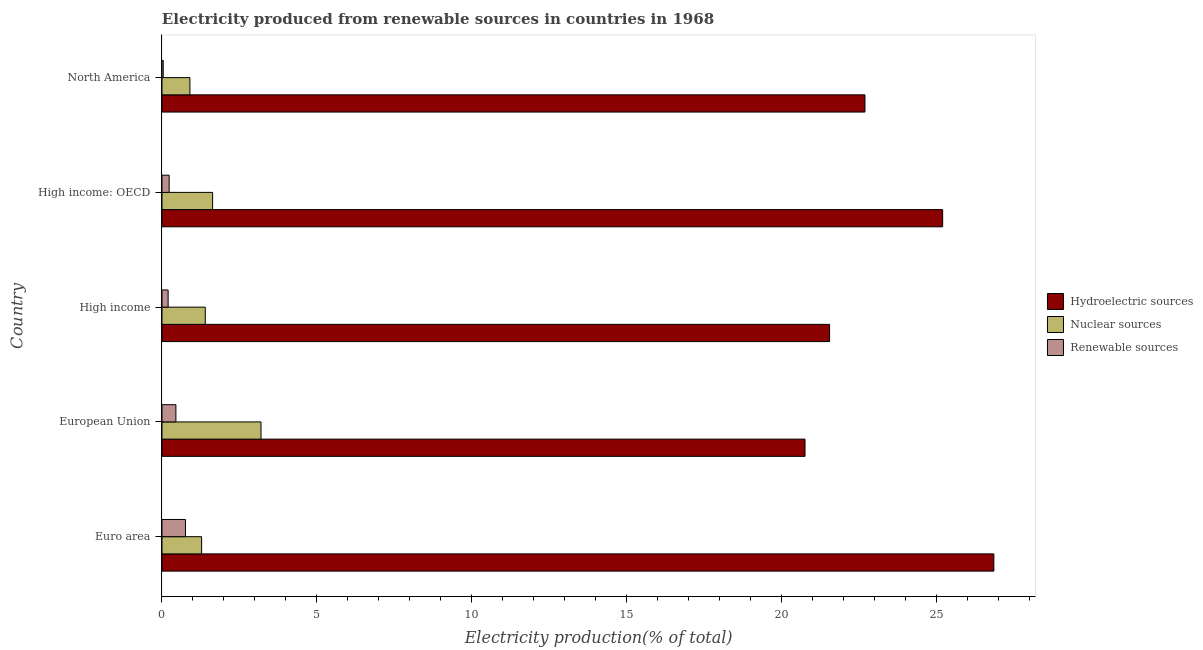How many different coloured bars are there?
Your answer should be very brief. 3. Are the number of bars per tick equal to the number of legend labels?
Your answer should be compact. Yes. Are the number of bars on each tick of the Y-axis equal?
Ensure brevity in your answer.  Yes. How many bars are there on the 1st tick from the top?
Keep it short and to the point. 3. What is the percentage of electricity produced by renewable sources in European Union?
Offer a very short reply. 0.45. Across all countries, what is the maximum percentage of electricity produced by hydroelectric sources?
Ensure brevity in your answer.  26.85. Across all countries, what is the minimum percentage of electricity produced by hydroelectric sources?
Offer a terse response. 20.75. In which country was the percentage of electricity produced by renewable sources maximum?
Offer a terse response. Euro area. What is the total percentage of electricity produced by renewable sources in the graph?
Your response must be concise. 1.68. What is the difference between the percentage of electricity produced by nuclear sources in Euro area and that in High income?
Your answer should be compact. -0.12. What is the difference between the percentage of electricity produced by hydroelectric sources in Euro area and the percentage of electricity produced by nuclear sources in High income: OECD?
Your answer should be compact. 25.21. What is the average percentage of electricity produced by hydroelectric sources per country?
Ensure brevity in your answer.  23.4. What is the difference between the percentage of electricity produced by hydroelectric sources and percentage of electricity produced by renewable sources in European Union?
Your answer should be very brief. 20.3. What is the ratio of the percentage of electricity produced by hydroelectric sources in European Union to that in High income?
Offer a very short reply. 0.96. Is the percentage of electricity produced by renewable sources in High income less than that in High income: OECD?
Provide a short and direct response. Yes. Is the difference between the percentage of electricity produced by hydroelectric sources in High income: OECD and North America greater than the difference between the percentage of electricity produced by renewable sources in High income: OECD and North America?
Make the answer very short. Yes. What is the difference between the highest and the second highest percentage of electricity produced by nuclear sources?
Keep it short and to the point. 1.56. What is the difference between the highest and the lowest percentage of electricity produced by nuclear sources?
Offer a very short reply. 2.29. What does the 2nd bar from the top in North America represents?
Offer a very short reply. Nuclear sources. What does the 3rd bar from the bottom in High income represents?
Offer a terse response. Renewable sources. How many bars are there?
Your answer should be very brief. 15. Are all the bars in the graph horizontal?
Provide a short and direct response. Yes. Are the values on the major ticks of X-axis written in scientific E-notation?
Provide a succinct answer. No. Does the graph contain any zero values?
Provide a short and direct response. No. Does the graph contain grids?
Your answer should be compact. No. Where does the legend appear in the graph?
Offer a terse response. Center right. How many legend labels are there?
Your answer should be compact. 3. What is the title of the graph?
Offer a terse response. Electricity produced from renewable sources in countries in 1968. Does "Resident buildings and public services" appear as one of the legend labels in the graph?
Give a very brief answer. No. What is the label or title of the X-axis?
Provide a succinct answer. Electricity production(% of total). What is the label or title of the Y-axis?
Keep it short and to the point. Country. What is the Electricity production(% of total) in Hydroelectric sources in Euro area?
Provide a short and direct response. 26.85. What is the Electricity production(% of total) of Nuclear sources in Euro area?
Keep it short and to the point. 1.28. What is the Electricity production(% of total) of Renewable sources in Euro area?
Offer a very short reply. 0.76. What is the Electricity production(% of total) in Hydroelectric sources in European Union?
Give a very brief answer. 20.75. What is the Electricity production(% of total) of Nuclear sources in European Union?
Give a very brief answer. 3.2. What is the Electricity production(% of total) of Renewable sources in European Union?
Provide a succinct answer. 0.45. What is the Electricity production(% of total) of Hydroelectric sources in High income?
Your answer should be compact. 21.54. What is the Electricity production(% of total) in Nuclear sources in High income?
Provide a short and direct response. 1.4. What is the Electricity production(% of total) of Renewable sources in High income?
Your answer should be compact. 0.2. What is the Electricity production(% of total) of Hydroelectric sources in High income: OECD?
Your response must be concise. 25.19. What is the Electricity production(% of total) in Nuclear sources in High income: OECD?
Your answer should be very brief. 1.63. What is the Electricity production(% of total) in Renewable sources in High income: OECD?
Your answer should be compact. 0.23. What is the Electricity production(% of total) of Hydroelectric sources in North America?
Keep it short and to the point. 22.69. What is the Electricity production(% of total) in Nuclear sources in North America?
Provide a succinct answer. 0.9. What is the Electricity production(% of total) in Renewable sources in North America?
Offer a terse response. 0.04. Across all countries, what is the maximum Electricity production(% of total) in Hydroelectric sources?
Your response must be concise. 26.85. Across all countries, what is the maximum Electricity production(% of total) of Nuclear sources?
Your answer should be very brief. 3.2. Across all countries, what is the maximum Electricity production(% of total) of Renewable sources?
Offer a terse response. 0.76. Across all countries, what is the minimum Electricity production(% of total) of Hydroelectric sources?
Make the answer very short. 20.75. Across all countries, what is the minimum Electricity production(% of total) of Nuclear sources?
Give a very brief answer. 0.9. Across all countries, what is the minimum Electricity production(% of total) in Renewable sources?
Your response must be concise. 0.04. What is the total Electricity production(% of total) in Hydroelectric sources in the graph?
Offer a very short reply. 117.02. What is the total Electricity production(% of total) in Nuclear sources in the graph?
Your response must be concise. 8.41. What is the total Electricity production(% of total) of Renewable sources in the graph?
Offer a very short reply. 1.68. What is the difference between the Electricity production(% of total) of Hydroelectric sources in Euro area and that in European Union?
Your answer should be compact. 6.09. What is the difference between the Electricity production(% of total) of Nuclear sources in Euro area and that in European Union?
Offer a terse response. -1.92. What is the difference between the Electricity production(% of total) in Renewable sources in Euro area and that in European Union?
Your response must be concise. 0.31. What is the difference between the Electricity production(% of total) of Hydroelectric sources in Euro area and that in High income?
Make the answer very short. 5.3. What is the difference between the Electricity production(% of total) of Nuclear sources in Euro area and that in High income?
Your answer should be very brief. -0.12. What is the difference between the Electricity production(% of total) in Renewable sources in Euro area and that in High income?
Keep it short and to the point. 0.56. What is the difference between the Electricity production(% of total) in Hydroelectric sources in Euro area and that in High income: OECD?
Provide a succinct answer. 1.65. What is the difference between the Electricity production(% of total) of Nuclear sources in Euro area and that in High income: OECD?
Provide a short and direct response. -0.36. What is the difference between the Electricity production(% of total) of Renewable sources in Euro area and that in High income: OECD?
Offer a terse response. 0.53. What is the difference between the Electricity production(% of total) in Hydroelectric sources in Euro area and that in North America?
Your response must be concise. 4.16. What is the difference between the Electricity production(% of total) in Nuclear sources in Euro area and that in North America?
Ensure brevity in your answer.  0.38. What is the difference between the Electricity production(% of total) in Renewable sources in Euro area and that in North America?
Provide a short and direct response. 0.72. What is the difference between the Electricity production(% of total) of Hydroelectric sources in European Union and that in High income?
Provide a succinct answer. -0.79. What is the difference between the Electricity production(% of total) in Nuclear sources in European Union and that in High income?
Ensure brevity in your answer.  1.8. What is the difference between the Electricity production(% of total) of Renewable sources in European Union and that in High income?
Your answer should be very brief. 0.25. What is the difference between the Electricity production(% of total) of Hydroelectric sources in European Union and that in High income: OECD?
Offer a terse response. -4.44. What is the difference between the Electricity production(% of total) of Nuclear sources in European Union and that in High income: OECD?
Keep it short and to the point. 1.56. What is the difference between the Electricity production(% of total) in Renewable sources in European Union and that in High income: OECD?
Give a very brief answer. 0.22. What is the difference between the Electricity production(% of total) in Hydroelectric sources in European Union and that in North America?
Your response must be concise. -1.93. What is the difference between the Electricity production(% of total) of Nuclear sources in European Union and that in North America?
Offer a very short reply. 2.29. What is the difference between the Electricity production(% of total) in Renewable sources in European Union and that in North America?
Offer a very short reply. 0.41. What is the difference between the Electricity production(% of total) in Hydroelectric sources in High income and that in High income: OECD?
Make the answer very short. -3.65. What is the difference between the Electricity production(% of total) of Nuclear sources in High income and that in High income: OECD?
Offer a very short reply. -0.24. What is the difference between the Electricity production(% of total) in Renewable sources in High income and that in High income: OECD?
Make the answer very short. -0.03. What is the difference between the Electricity production(% of total) of Hydroelectric sources in High income and that in North America?
Offer a very short reply. -1.14. What is the difference between the Electricity production(% of total) of Nuclear sources in High income and that in North America?
Offer a very short reply. 0.5. What is the difference between the Electricity production(% of total) in Renewable sources in High income and that in North America?
Provide a short and direct response. 0.16. What is the difference between the Electricity production(% of total) of Hydroelectric sources in High income: OECD and that in North America?
Keep it short and to the point. 2.51. What is the difference between the Electricity production(% of total) of Nuclear sources in High income: OECD and that in North America?
Offer a very short reply. 0.73. What is the difference between the Electricity production(% of total) in Renewable sources in High income: OECD and that in North America?
Make the answer very short. 0.19. What is the difference between the Electricity production(% of total) of Hydroelectric sources in Euro area and the Electricity production(% of total) of Nuclear sources in European Union?
Offer a very short reply. 23.65. What is the difference between the Electricity production(% of total) in Hydroelectric sources in Euro area and the Electricity production(% of total) in Renewable sources in European Union?
Provide a succinct answer. 26.4. What is the difference between the Electricity production(% of total) in Nuclear sources in Euro area and the Electricity production(% of total) in Renewable sources in European Union?
Your answer should be compact. 0.83. What is the difference between the Electricity production(% of total) of Hydroelectric sources in Euro area and the Electricity production(% of total) of Nuclear sources in High income?
Your answer should be compact. 25.45. What is the difference between the Electricity production(% of total) of Hydroelectric sources in Euro area and the Electricity production(% of total) of Renewable sources in High income?
Ensure brevity in your answer.  26.65. What is the difference between the Electricity production(% of total) in Nuclear sources in Euro area and the Electricity production(% of total) in Renewable sources in High income?
Give a very brief answer. 1.08. What is the difference between the Electricity production(% of total) of Hydroelectric sources in Euro area and the Electricity production(% of total) of Nuclear sources in High income: OECD?
Your response must be concise. 25.21. What is the difference between the Electricity production(% of total) in Hydroelectric sources in Euro area and the Electricity production(% of total) in Renewable sources in High income: OECD?
Provide a succinct answer. 26.61. What is the difference between the Electricity production(% of total) in Nuclear sources in Euro area and the Electricity production(% of total) in Renewable sources in High income: OECD?
Provide a short and direct response. 1.05. What is the difference between the Electricity production(% of total) of Hydroelectric sources in Euro area and the Electricity production(% of total) of Nuclear sources in North America?
Provide a succinct answer. 25.94. What is the difference between the Electricity production(% of total) in Hydroelectric sources in Euro area and the Electricity production(% of total) in Renewable sources in North America?
Offer a very short reply. 26.81. What is the difference between the Electricity production(% of total) of Nuclear sources in Euro area and the Electricity production(% of total) of Renewable sources in North America?
Your answer should be compact. 1.24. What is the difference between the Electricity production(% of total) in Hydroelectric sources in European Union and the Electricity production(% of total) in Nuclear sources in High income?
Your answer should be compact. 19.35. What is the difference between the Electricity production(% of total) of Hydroelectric sources in European Union and the Electricity production(% of total) of Renewable sources in High income?
Provide a short and direct response. 20.55. What is the difference between the Electricity production(% of total) in Nuclear sources in European Union and the Electricity production(% of total) in Renewable sources in High income?
Ensure brevity in your answer.  3. What is the difference between the Electricity production(% of total) in Hydroelectric sources in European Union and the Electricity production(% of total) in Nuclear sources in High income: OECD?
Make the answer very short. 19.12. What is the difference between the Electricity production(% of total) in Hydroelectric sources in European Union and the Electricity production(% of total) in Renewable sources in High income: OECD?
Your answer should be compact. 20.52. What is the difference between the Electricity production(% of total) of Nuclear sources in European Union and the Electricity production(% of total) of Renewable sources in High income: OECD?
Offer a very short reply. 2.96. What is the difference between the Electricity production(% of total) in Hydroelectric sources in European Union and the Electricity production(% of total) in Nuclear sources in North America?
Provide a succinct answer. 19.85. What is the difference between the Electricity production(% of total) of Hydroelectric sources in European Union and the Electricity production(% of total) of Renewable sources in North America?
Your response must be concise. 20.71. What is the difference between the Electricity production(% of total) in Nuclear sources in European Union and the Electricity production(% of total) in Renewable sources in North America?
Offer a very short reply. 3.16. What is the difference between the Electricity production(% of total) in Hydroelectric sources in High income and the Electricity production(% of total) in Nuclear sources in High income: OECD?
Give a very brief answer. 19.91. What is the difference between the Electricity production(% of total) in Hydroelectric sources in High income and the Electricity production(% of total) in Renewable sources in High income: OECD?
Your answer should be very brief. 21.31. What is the difference between the Electricity production(% of total) of Nuclear sources in High income and the Electricity production(% of total) of Renewable sources in High income: OECD?
Keep it short and to the point. 1.17. What is the difference between the Electricity production(% of total) of Hydroelectric sources in High income and the Electricity production(% of total) of Nuclear sources in North America?
Ensure brevity in your answer.  20.64. What is the difference between the Electricity production(% of total) in Hydroelectric sources in High income and the Electricity production(% of total) in Renewable sources in North America?
Ensure brevity in your answer.  21.5. What is the difference between the Electricity production(% of total) of Nuclear sources in High income and the Electricity production(% of total) of Renewable sources in North America?
Give a very brief answer. 1.36. What is the difference between the Electricity production(% of total) in Hydroelectric sources in High income: OECD and the Electricity production(% of total) in Nuclear sources in North America?
Your answer should be very brief. 24.29. What is the difference between the Electricity production(% of total) of Hydroelectric sources in High income: OECD and the Electricity production(% of total) of Renewable sources in North America?
Provide a succinct answer. 25.15. What is the difference between the Electricity production(% of total) in Nuclear sources in High income: OECD and the Electricity production(% of total) in Renewable sources in North America?
Offer a very short reply. 1.59. What is the average Electricity production(% of total) in Hydroelectric sources per country?
Give a very brief answer. 23.4. What is the average Electricity production(% of total) of Nuclear sources per country?
Your answer should be very brief. 1.68. What is the average Electricity production(% of total) in Renewable sources per country?
Provide a short and direct response. 0.34. What is the difference between the Electricity production(% of total) in Hydroelectric sources and Electricity production(% of total) in Nuclear sources in Euro area?
Your answer should be very brief. 25.57. What is the difference between the Electricity production(% of total) of Hydroelectric sources and Electricity production(% of total) of Renewable sources in Euro area?
Your response must be concise. 26.09. What is the difference between the Electricity production(% of total) of Nuclear sources and Electricity production(% of total) of Renewable sources in Euro area?
Ensure brevity in your answer.  0.52. What is the difference between the Electricity production(% of total) in Hydroelectric sources and Electricity production(% of total) in Nuclear sources in European Union?
Give a very brief answer. 17.56. What is the difference between the Electricity production(% of total) of Hydroelectric sources and Electricity production(% of total) of Renewable sources in European Union?
Your answer should be compact. 20.3. What is the difference between the Electricity production(% of total) of Nuclear sources and Electricity production(% of total) of Renewable sources in European Union?
Your response must be concise. 2.75. What is the difference between the Electricity production(% of total) of Hydroelectric sources and Electricity production(% of total) of Nuclear sources in High income?
Provide a short and direct response. 20.15. What is the difference between the Electricity production(% of total) in Hydroelectric sources and Electricity production(% of total) in Renewable sources in High income?
Ensure brevity in your answer.  21.35. What is the difference between the Electricity production(% of total) in Nuclear sources and Electricity production(% of total) in Renewable sources in High income?
Ensure brevity in your answer.  1.2. What is the difference between the Electricity production(% of total) of Hydroelectric sources and Electricity production(% of total) of Nuclear sources in High income: OECD?
Make the answer very short. 23.56. What is the difference between the Electricity production(% of total) of Hydroelectric sources and Electricity production(% of total) of Renewable sources in High income: OECD?
Offer a terse response. 24.96. What is the difference between the Electricity production(% of total) in Nuclear sources and Electricity production(% of total) in Renewable sources in High income: OECD?
Provide a short and direct response. 1.4. What is the difference between the Electricity production(% of total) in Hydroelectric sources and Electricity production(% of total) in Nuclear sources in North America?
Provide a succinct answer. 21.78. What is the difference between the Electricity production(% of total) of Hydroelectric sources and Electricity production(% of total) of Renewable sources in North America?
Your answer should be very brief. 22.65. What is the difference between the Electricity production(% of total) in Nuclear sources and Electricity production(% of total) in Renewable sources in North America?
Make the answer very short. 0.86. What is the ratio of the Electricity production(% of total) in Hydroelectric sources in Euro area to that in European Union?
Your response must be concise. 1.29. What is the ratio of the Electricity production(% of total) of Nuclear sources in Euro area to that in European Union?
Your answer should be compact. 0.4. What is the ratio of the Electricity production(% of total) in Renewable sources in Euro area to that in European Union?
Offer a terse response. 1.69. What is the ratio of the Electricity production(% of total) in Hydroelectric sources in Euro area to that in High income?
Keep it short and to the point. 1.25. What is the ratio of the Electricity production(% of total) of Nuclear sources in Euro area to that in High income?
Your response must be concise. 0.92. What is the ratio of the Electricity production(% of total) of Renewable sources in Euro area to that in High income?
Your answer should be compact. 3.83. What is the ratio of the Electricity production(% of total) in Hydroelectric sources in Euro area to that in High income: OECD?
Keep it short and to the point. 1.07. What is the ratio of the Electricity production(% of total) in Nuclear sources in Euro area to that in High income: OECD?
Provide a succinct answer. 0.78. What is the ratio of the Electricity production(% of total) in Renewable sources in Euro area to that in High income: OECD?
Give a very brief answer. 3.27. What is the ratio of the Electricity production(% of total) of Hydroelectric sources in Euro area to that in North America?
Your answer should be very brief. 1.18. What is the ratio of the Electricity production(% of total) of Nuclear sources in Euro area to that in North America?
Keep it short and to the point. 1.42. What is the ratio of the Electricity production(% of total) of Renewable sources in Euro area to that in North America?
Your response must be concise. 19.13. What is the ratio of the Electricity production(% of total) in Hydroelectric sources in European Union to that in High income?
Your response must be concise. 0.96. What is the ratio of the Electricity production(% of total) of Nuclear sources in European Union to that in High income?
Make the answer very short. 2.29. What is the ratio of the Electricity production(% of total) of Renewable sources in European Union to that in High income?
Offer a very short reply. 2.27. What is the ratio of the Electricity production(% of total) of Hydroelectric sources in European Union to that in High income: OECD?
Make the answer very short. 0.82. What is the ratio of the Electricity production(% of total) of Nuclear sources in European Union to that in High income: OECD?
Your answer should be very brief. 1.96. What is the ratio of the Electricity production(% of total) in Renewable sources in European Union to that in High income: OECD?
Keep it short and to the point. 1.94. What is the ratio of the Electricity production(% of total) in Hydroelectric sources in European Union to that in North America?
Offer a very short reply. 0.91. What is the ratio of the Electricity production(% of total) of Nuclear sources in European Union to that in North America?
Provide a succinct answer. 3.54. What is the ratio of the Electricity production(% of total) of Renewable sources in European Union to that in North America?
Your answer should be very brief. 11.35. What is the ratio of the Electricity production(% of total) of Hydroelectric sources in High income to that in High income: OECD?
Give a very brief answer. 0.86. What is the ratio of the Electricity production(% of total) in Nuclear sources in High income to that in High income: OECD?
Your answer should be compact. 0.86. What is the ratio of the Electricity production(% of total) in Renewable sources in High income to that in High income: OECD?
Provide a succinct answer. 0.86. What is the ratio of the Electricity production(% of total) in Hydroelectric sources in High income to that in North America?
Keep it short and to the point. 0.95. What is the ratio of the Electricity production(% of total) of Nuclear sources in High income to that in North America?
Keep it short and to the point. 1.55. What is the ratio of the Electricity production(% of total) of Renewable sources in High income to that in North America?
Provide a short and direct response. 5. What is the ratio of the Electricity production(% of total) in Hydroelectric sources in High income: OECD to that in North America?
Make the answer very short. 1.11. What is the ratio of the Electricity production(% of total) in Nuclear sources in High income: OECD to that in North America?
Keep it short and to the point. 1.81. What is the ratio of the Electricity production(% of total) of Renewable sources in High income: OECD to that in North America?
Your response must be concise. 5.85. What is the difference between the highest and the second highest Electricity production(% of total) of Hydroelectric sources?
Provide a succinct answer. 1.65. What is the difference between the highest and the second highest Electricity production(% of total) of Nuclear sources?
Offer a terse response. 1.56. What is the difference between the highest and the second highest Electricity production(% of total) in Renewable sources?
Your answer should be very brief. 0.31. What is the difference between the highest and the lowest Electricity production(% of total) in Hydroelectric sources?
Your answer should be compact. 6.09. What is the difference between the highest and the lowest Electricity production(% of total) in Nuclear sources?
Make the answer very short. 2.29. What is the difference between the highest and the lowest Electricity production(% of total) in Renewable sources?
Provide a succinct answer. 0.72. 